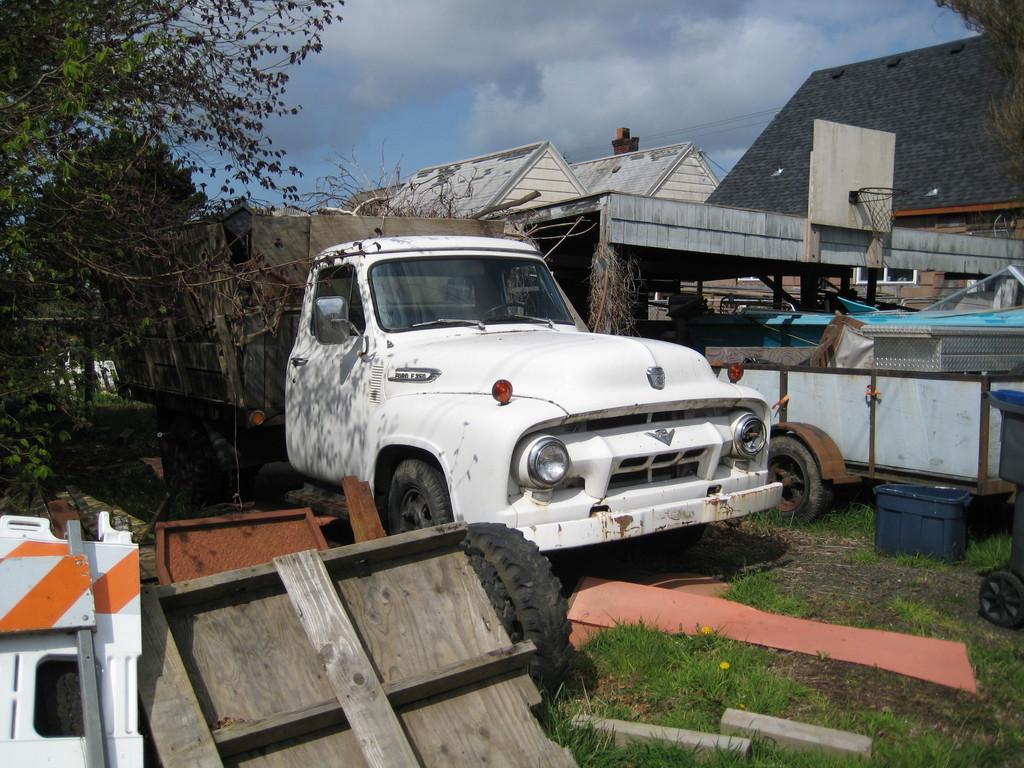Can you describe this image briefly? In this image, we can see a white color car and there is a basketball net, at the left side there is a green color plant, we can see some homes, at the top there is a sky. 